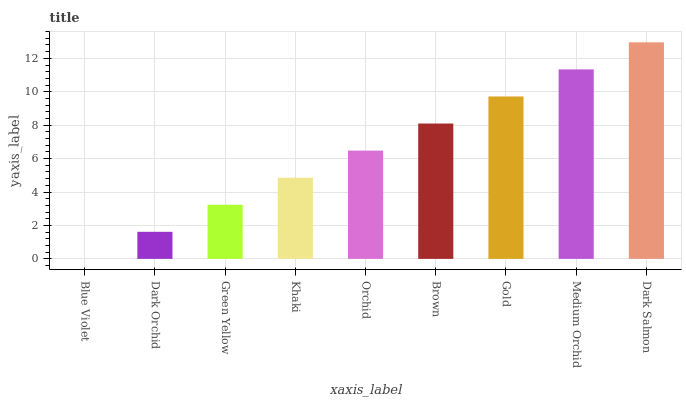Is Blue Violet the minimum?
Answer yes or no. Yes. Is Dark Salmon the maximum?
Answer yes or no. Yes. Is Dark Orchid the minimum?
Answer yes or no. No. Is Dark Orchid the maximum?
Answer yes or no. No. Is Dark Orchid greater than Blue Violet?
Answer yes or no. Yes. Is Blue Violet less than Dark Orchid?
Answer yes or no. Yes. Is Blue Violet greater than Dark Orchid?
Answer yes or no. No. Is Dark Orchid less than Blue Violet?
Answer yes or no. No. Is Orchid the high median?
Answer yes or no. Yes. Is Orchid the low median?
Answer yes or no. Yes. Is Green Yellow the high median?
Answer yes or no. No. Is Brown the low median?
Answer yes or no. No. 